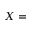<formula> <loc_0><loc_0><loc_500><loc_500>X =</formula> 